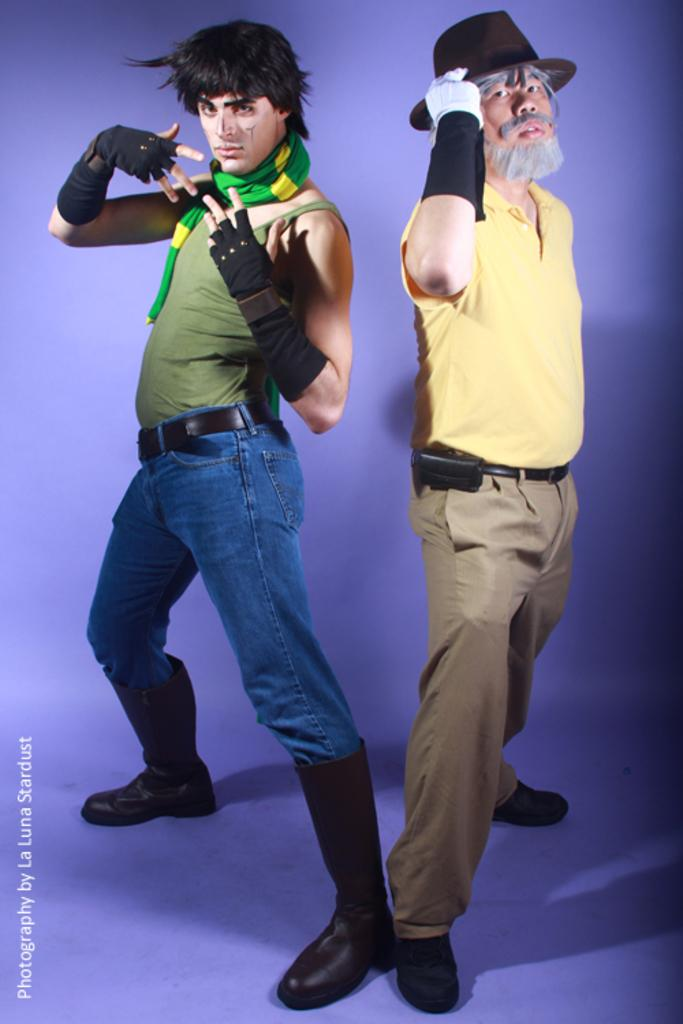How many people are in the image? There are two persons in the image. What are the persons doing in the image? The persons are posing. Is there any text present in the image? Yes, there is text at the bottom of the image. What force is being applied by the persons in the image? There is no indication of any force being applied by the persons in the image; they are simply posing. 